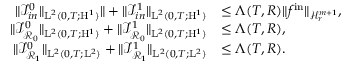Convert formula to latex. <formula><loc_0><loc_0><loc_500><loc_500>\begin{array} { r l } { \| \mathcal { I } _ { i n } ^ { 0 } \| _ { L ^ { 2 } ( 0 , T ; H ^ { 1 } ) } \| + \| \mathcal { I } _ { i n } ^ { 1 } \| _ { L ^ { 2 } ( 0 , T ; H ^ { 1 } ) } } & { \leq \Lambda ( T , R ) \| f ^ { i n } \| _ { \mathcal { H } _ { r } ^ { m + 1 } } , } \\ { \| \mathcal { I } _ { \mathcal { R } _ { 0 } } ^ { 0 } \| _ { L ^ { 2 } ( 0 , T ; H ^ { 1 } ) } + \| \mathcal { I } _ { \mathcal { R } _ { 0 } } ^ { 1 } \| _ { L ^ { 2 } ( 0 , T ; H ^ { 1 } ) } } & { \leq \Lambda ( T , R ) , } \\ { \| \mathcal { I } _ { \mathcal { R } _ { 1 } } ^ { 0 } \| _ { L ^ { 2 } ( 0 , T ; L ^ { 2 } ) } + \| \mathcal { I } _ { \mathcal { R } _ { 1 } } ^ { 1 } \| _ { L ^ { 2 } ( 0 , T ; L ^ { 2 } ) } } & { \leq \Lambda ( T , R ) . } \end{array}</formula> 